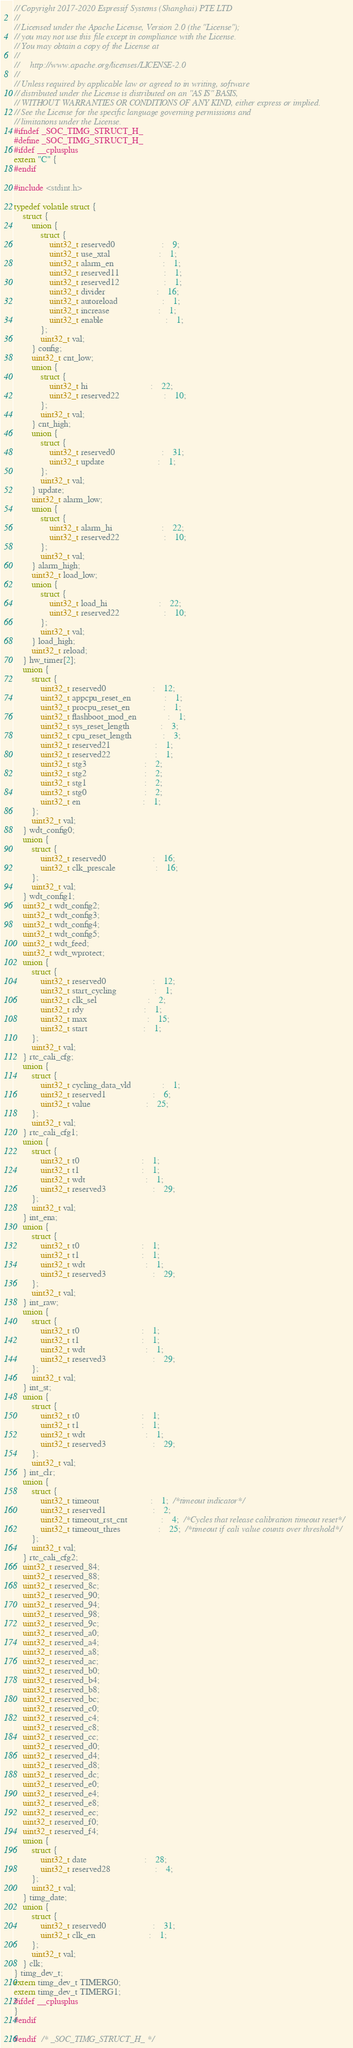<code> <loc_0><loc_0><loc_500><loc_500><_C_>// Copyright 2017-2020 Espressif Systems (Shanghai) PTE LTD
//
// Licensed under the Apache License, Version 2.0 (the "License");
// you may not use this file except in compliance with the License.
// You may obtain a copy of the License at
//
//     http://www.apache.org/licenses/LICENSE-2.0
//
// Unless required by applicable law or agreed to in writing, software
// distributed under the License is distributed on an "AS IS" BASIS,
// WITHOUT WARRANTIES OR CONDITIONS OF ANY KIND, either express or implied.
// See the License for the specific language governing permissions and
// limitations under the License.
#ifndef _SOC_TIMG_STRUCT_H_
#define _SOC_TIMG_STRUCT_H_
#ifdef __cplusplus
extern "C" {
#endif

#include <stdint.h>

typedef volatile struct {
    struct {
        union {
            struct {
                uint32_t reserved0                     :    9;
                uint32_t use_xtal                      :    1;
                uint32_t alarm_en                      :    1;
                uint32_t reserved11                    :    1;
                uint32_t reserved12                    :    1;
                uint32_t divider                       :    16;
                uint32_t autoreload                    :    1;
                uint32_t increase                      :    1;
                uint32_t enable                            :    1;
            };
            uint32_t val;
        } config;
        uint32_t cnt_low;
        union {
            struct {
                uint32_t hi                            :    22;
                uint32_t reserved22                    :    10;
            };
            uint32_t val;
        } cnt_high;
        union {
            struct {
                uint32_t reserved0                     :    31;
                uint32_t update                        :    1;
            };
            uint32_t val;
        } update;
        uint32_t alarm_low;
        union {
            struct {
                uint32_t alarm_hi                      :    22;
                uint32_t reserved22                    :    10;
            };
            uint32_t val;
        } alarm_high;
        uint32_t load_low;
        union {
            struct {
                uint32_t load_hi                       :    22;
                uint32_t reserved22                    :    10;
            };
            uint32_t val;
        } load_high;
        uint32_t reload;
    } hw_timer[2];
    union {
        struct {
            uint32_t reserved0                     :    12;
            uint32_t appcpu_reset_en               :    1;
            uint32_t procpu_reset_en               :    1;
            uint32_t flashboot_mod_en              :    1;
            uint32_t sys_reset_length              :    3;
            uint32_t cpu_reset_length              :    3;
            uint32_t reserved21                    :    1;
            uint32_t reserved22                    :    1;
            uint32_t stg3                          :    2;
            uint32_t stg2                          :    2;
            uint32_t stg1                          :    2;
            uint32_t stg0                          :    2;
            uint32_t en                            :    1;
        };
        uint32_t val;
    } wdt_config0;
    union {
        struct {
            uint32_t reserved0                     :    16;
            uint32_t clk_prescale                  :    16;
        };
        uint32_t val;
    } wdt_config1;
    uint32_t wdt_config2;
    uint32_t wdt_config3;
    uint32_t wdt_config4;
    uint32_t wdt_config5;
    uint32_t wdt_feed;
    uint32_t wdt_wprotect;
    union {
        struct {
            uint32_t reserved0                     :    12;
            uint32_t start_cycling                 :    1;
            uint32_t clk_sel                       :    2;
            uint32_t rdy                           :    1;
            uint32_t max                           :    15;
            uint32_t start                         :    1;
        };
        uint32_t val;
    } rtc_cali_cfg;
    union {
        struct {
            uint32_t cycling_data_vld              :    1;
            uint32_t reserved1                     :    6;
            uint32_t value                         :    25;
        };
        uint32_t val;
    } rtc_cali_cfg1;
    union {
        struct {
            uint32_t t0                            :    1;
            uint32_t t1                            :    1;
            uint32_t wdt                           :    1;
            uint32_t reserved3                     :    29;
        };
        uint32_t val;
    } int_ena;
    union {
        struct {
            uint32_t t0                            :    1;
            uint32_t t1                            :    1;
            uint32_t wdt                           :    1;
            uint32_t reserved3                     :    29;
        };
        uint32_t val;
    } int_raw;
    union {
        struct {
            uint32_t t0                            :    1;
            uint32_t t1                            :    1;
            uint32_t wdt                           :    1;
            uint32_t reserved3                     :    29;
        };
        uint32_t val;
    } int_st;
    union {
        struct {
            uint32_t t0                            :    1;
            uint32_t t1                            :    1;
            uint32_t wdt                           :    1;
            uint32_t reserved3                     :    29;
        };
        uint32_t val;
    } int_clr;
    union {
        struct {
            uint32_t timeout                       :    1;  /*timeout indicator*/
            uint32_t reserved1                     :    2;
            uint32_t timeout_rst_cnt               :    4;  /*Cycles that release calibration timeout reset*/
            uint32_t timeout_thres                 :    25;  /*timeout if cali value counts over threshold*/
        };
        uint32_t val;
    } rtc_cali_cfg2;
    uint32_t reserved_84;
    uint32_t reserved_88;
    uint32_t reserved_8c;
    uint32_t reserved_90;
    uint32_t reserved_94;
    uint32_t reserved_98;
    uint32_t reserved_9c;
    uint32_t reserved_a0;
    uint32_t reserved_a4;
    uint32_t reserved_a8;
    uint32_t reserved_ac;
    uint32_t reserved_b0;
    uint32_t reserved_b4;
    uint32_t reserved_b8;
    uint32_t reserved_bc;
    uint32_t reserved_c0;
    uint32_t reserved_c4;
    uint32_t reserved_c8;
    uint32_t reserved_cc;
    uint32_t reserved_d0;
    uint32_t reserved_d4;
    uint32_t reserved_d8;
    uint32_t reserved_dc;
    uint32_t reserved_e0;
    uint32_t reserved_e4;
    uint32_t reserved_e8;
    uint32_t reserved_ec;
    uint32_t reserved_f0;
    uint32_t reserved_f4;
    union {
        struct {
            uint32_t date                          :    28;
            uint32_t reserved28                    :    4;
        };
        uint32_t val;
    } timg_date;
    union {
        struct {
            uint32_t reserved0                     :    31;
            uint32_t clk_en                        :    1;
        };
        uint32_t val;
    } clk;
} timg_dev_t;
extern timg_dev_t TIMERG0;
extern timg_dev_t TIMERG1;
#ifdef __cplusplus
}
#endif

#endif  /* _SOC_TIMG_STRUCT_H_ */
</code> 